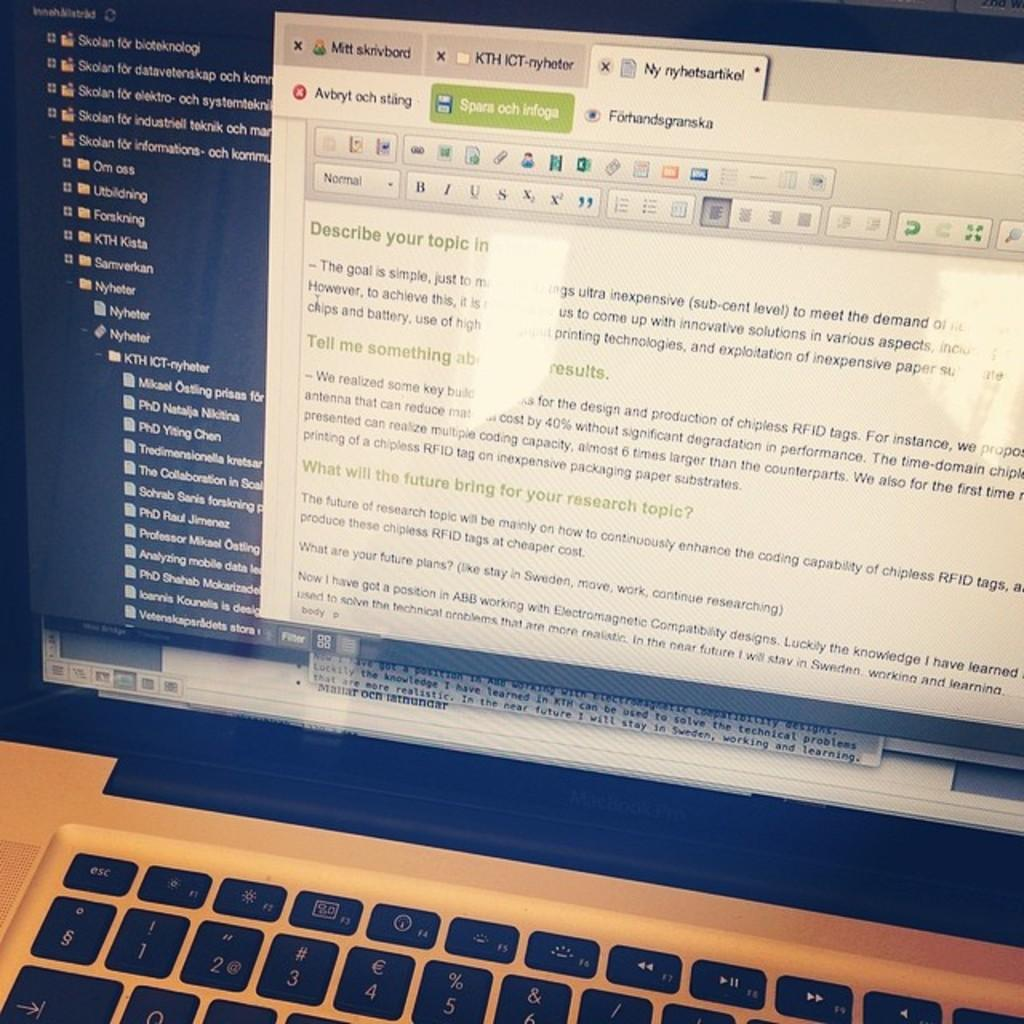<image>
Write a terse but informative summary of the picture. A laptop screen shows a web page with information about how to describe your topic. 